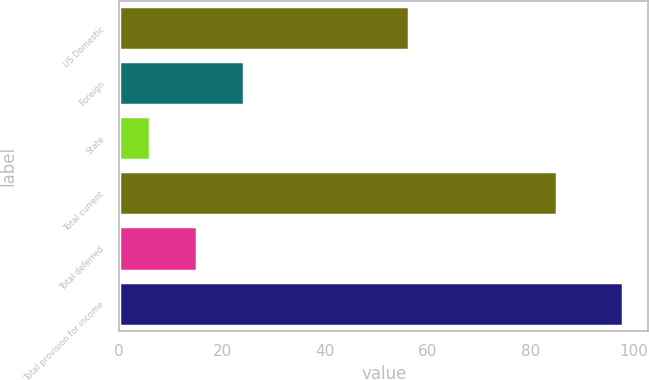<chart> <loc_0><loc_0><loc_500><loc_500><bar_chart><fcel>US Domestic<fcel>Foreign<fcel>State<fcel>Total current<fcel>Total deferred<fcel>Total provision for income<nl><fcel>56.3<fcel>24.3<fcel>5.9<fcel>85.1<fcel>15.1<fcel>97.9<nl></chart> 